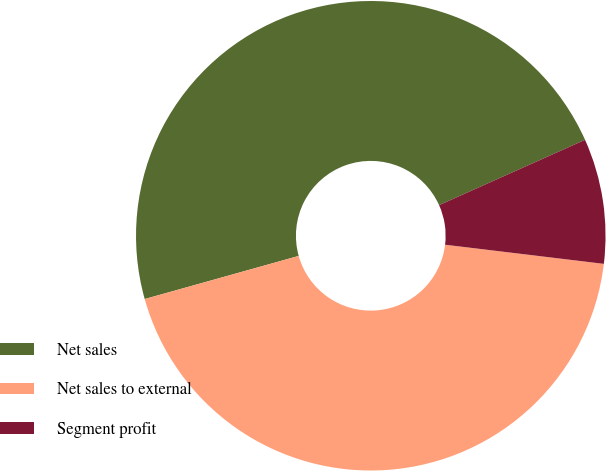<chart> <loc_0><loc_0><loc_500><loc_500><pie_chart><fcel>Net sales<fcel>Net sales to external<fcel>Segment profit<nl><fcel>47.65%<fcel>43.75%<fcel>8.61%<nl></chart> 